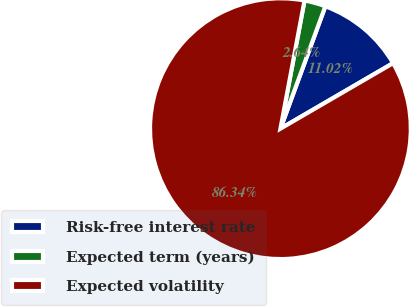Convert chart to OTSL. <chart><loc_0><loc_0><loc_500><loc_500><pie_chart><fcel>Risk-free interest rate<fcel>Expected term (years)<fcel>Expected volatility<nl><fcel>11.02%<fcel>2.64%<fcel>86.34%<nl></chart> 